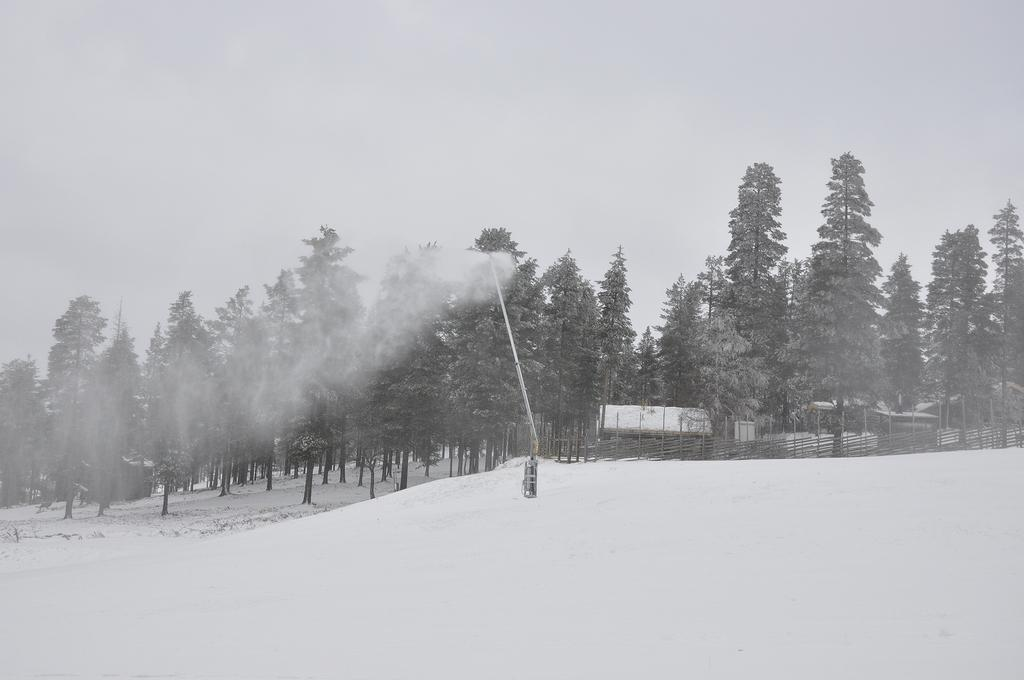What is covering the ground at the bottom of the image? There is snow at the bottom of the image. What is located on the snow? There is an object on the snow. What can be seen in the distance in the image? There are trees, houses, and a fence in the background of the image. What is visible above the background elements in the image? The sky is visible in the background of the image. What type of can does the daughter of the governor hold in the image? There is no can or daughter of the governor present in the image. 